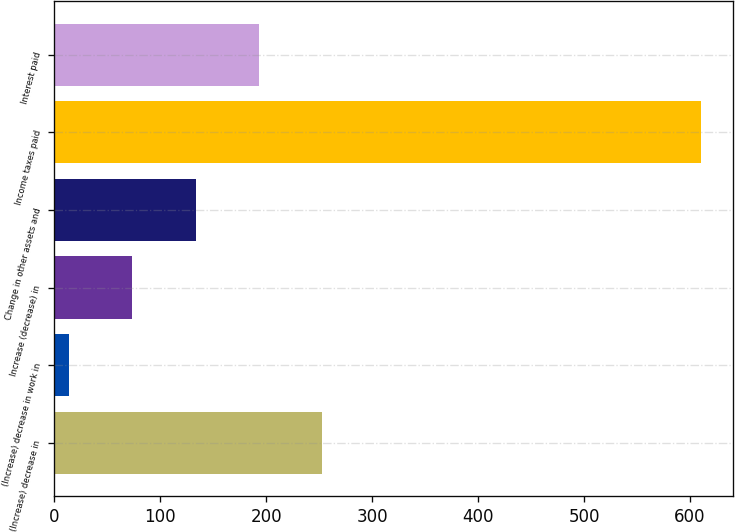<chart> <loc_0><loc_0><loc_500><loc_500><bar_chart><fcel>(Increase) decrease in<fcel>(Increase) decrease in work in<fcel>Increase (decrease) in<fcel>Change in other assets and<fcel>Income taxes paid<fcel>Interest paid<nl><fcel>252.56<fcel>14.2<fcel>73.79<fcel>133.38<fcel>610.1<fcel>192.97<nl></chart> 